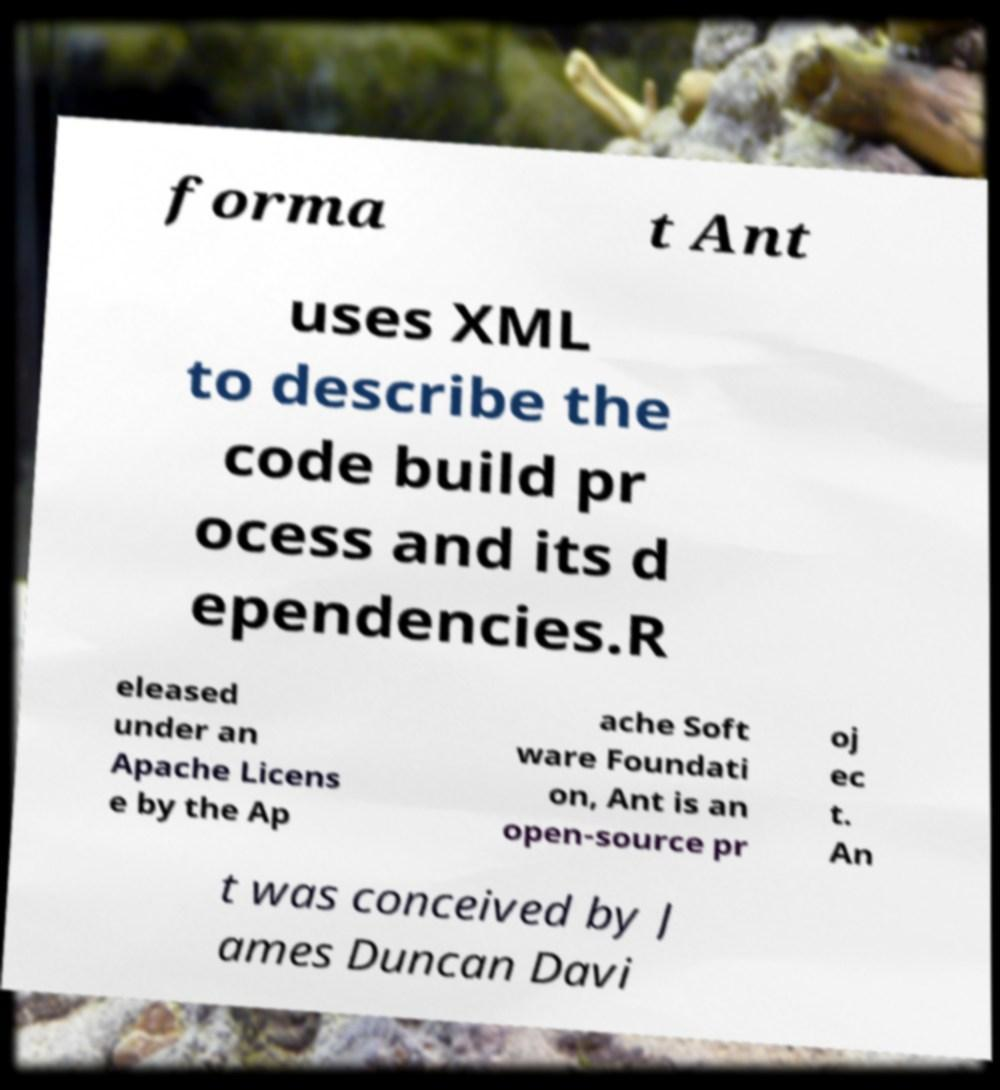For documentation purposes, I need the text within this image transcribed. Could you provide that? forma t Ant uses XML to describe the code build pr ocess and its d ependencies.R eleased under an Apache Licens e by the Ap ache Soft ware Foundati on, Ant is an open-source pr oj ec t. An t was conceived by J ames Duncan Davi 